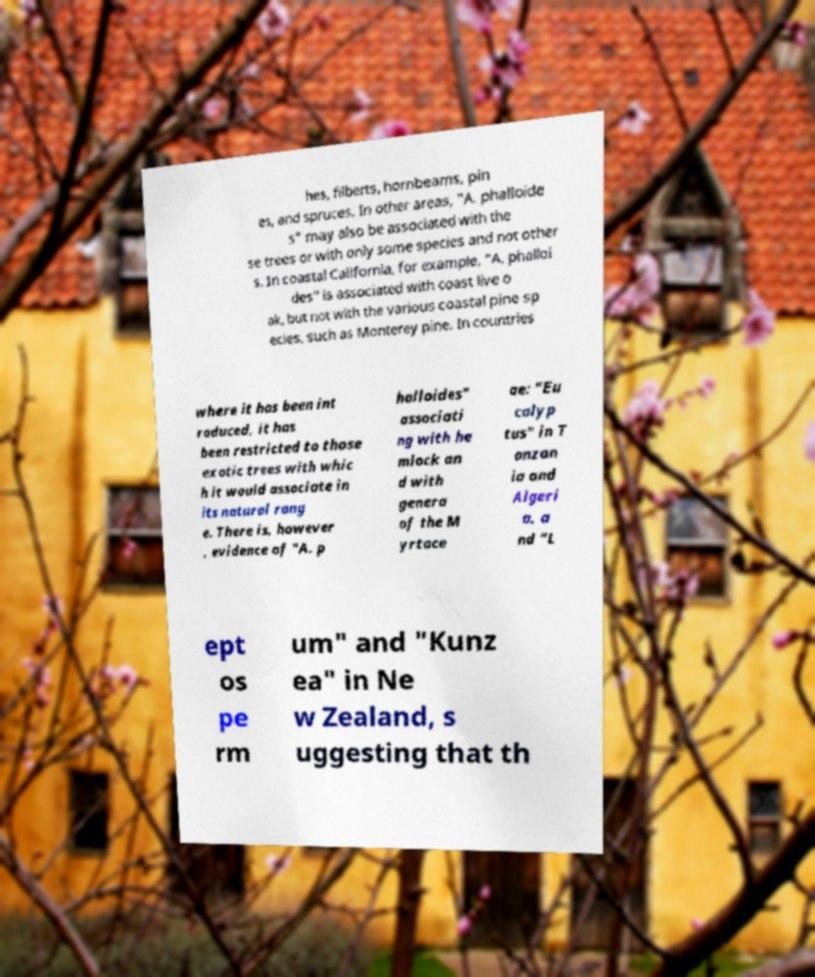Please identify and transcribe the text found in this image. hes, filberts, hornbeams, pin es, and spruces. In other areas, "A. phalloide s" may also be associated with the se trees or with only some species and not other s. In coastal California, for example, "A. phalloi des" is associated with coast live o ak, but not with the various coastal pine sp ecies, such as Monterey pine. In countries where it has been int roduced, it has been restricted to those exotic trees with whic h it would associate in its natural rang e. There is, however , evidence of "A. p halloides" associati ng with he mlock an d with genera of the M yrtace ae: "Eu calyp tus" in T anzan ia and Algeri a, a nd "L ept os pe rm um" and "Kunz ea" in Ne w Zealand, s uggesting that th 